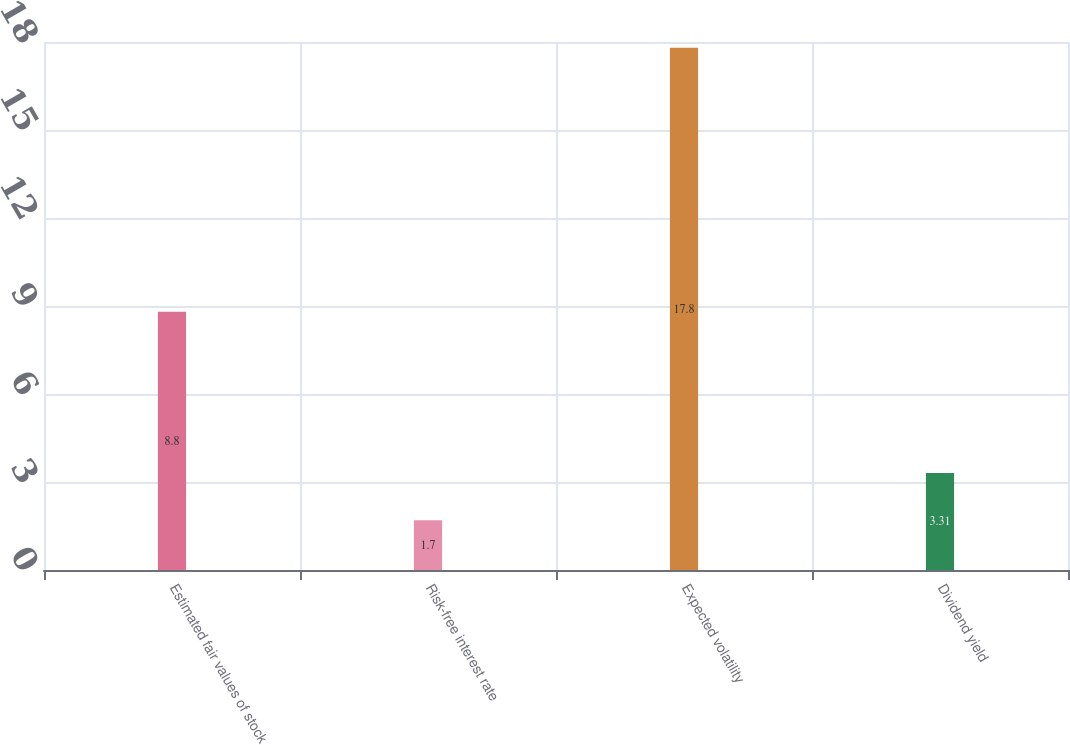Convert chart to OTSL. <chart><loc_0><loc_0><loc_500><loc_500><bar_chart><fcel>Estimated fair values of stock<fcel>Risk-free interest rate<fcel>Expected volatility<fcel>Dividend yield<nl><fcel>8.8<fcel>1.7<fcel>17.8<fcel>3.31<nl></chart> 